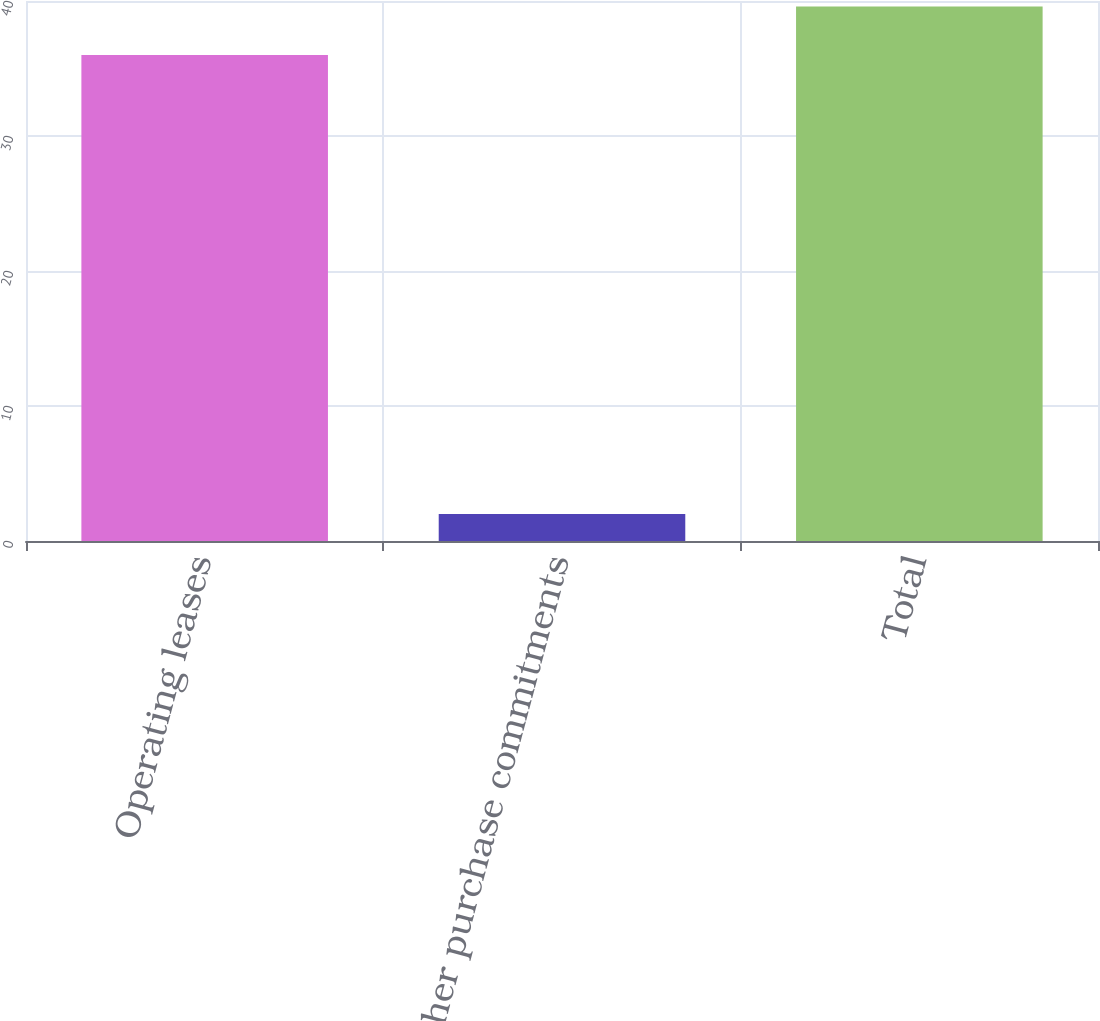Convert chart. <chart><loc_0><loc_0><loc_500><loc_500><bar_chart><fcel>Operating leases<fcel>Other purchase commitments<fcel>Total<nl><fcel>36<fcel>2<fcel>39.6<nl></chart> 